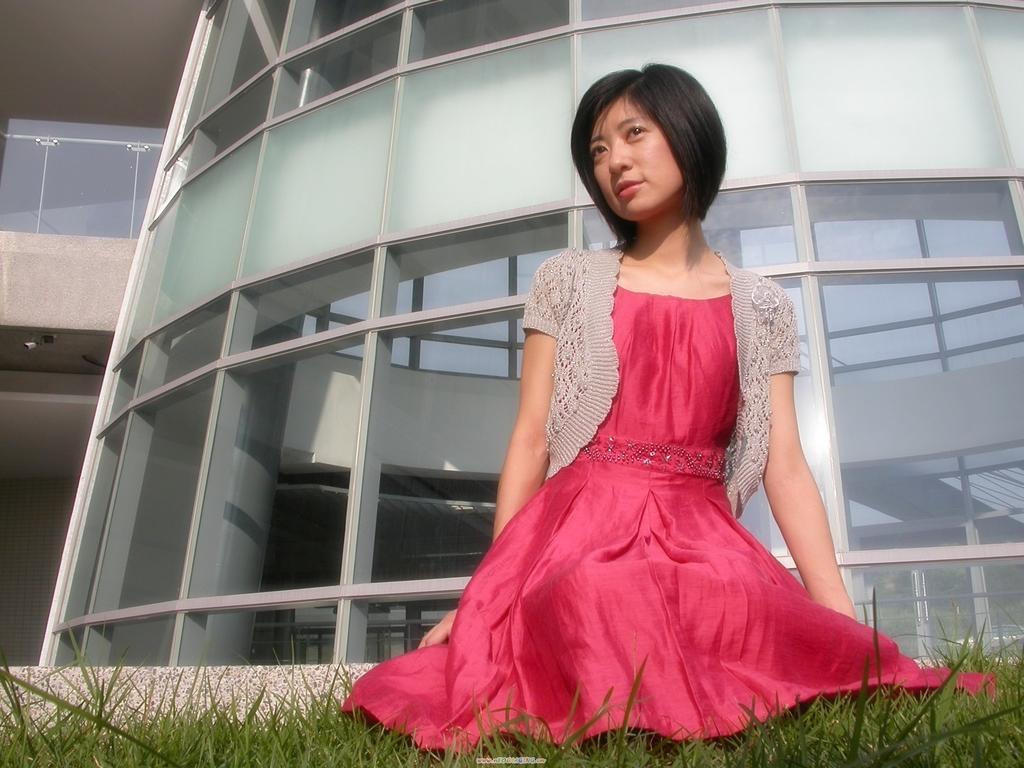Please provide a concise description of this image. In this picture we can see a woman here, at the bottom there is grass, in the background we can see a building, there is a glass here. 